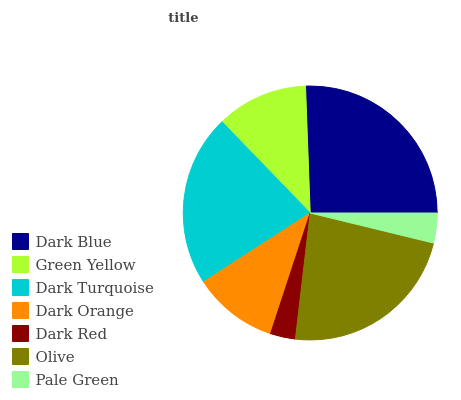Is Dark Red the minimum?
Answer yes or no. Yes. Is Dark Blue the maximum?
Answer yes or no. Yes. Is Green Yellow the minimum?
Answer yes or no. No. Is Green Yellow the maximum?
Answer yes or no. No. Is Dark Blue greater than Green Yellow?
Answer yes or no. Yes. Is Green Yellow less than Dark Blue?
Answer yes or no. Yes. Is Green Yellow greater than Dark Blue?
Answer yes or no. No. Is Dark Blue less than Green Yellow?
Answer yes or no. No. Is Green Yellow the high median?
Answer yes or no. Yes. Is Green Yellow the low median?
Answer yes or no. Yes. Is Dark Turquoise the high median?
Answer yes or no. No. Is Dark Orange the low median?
Answer yes or no. No. 